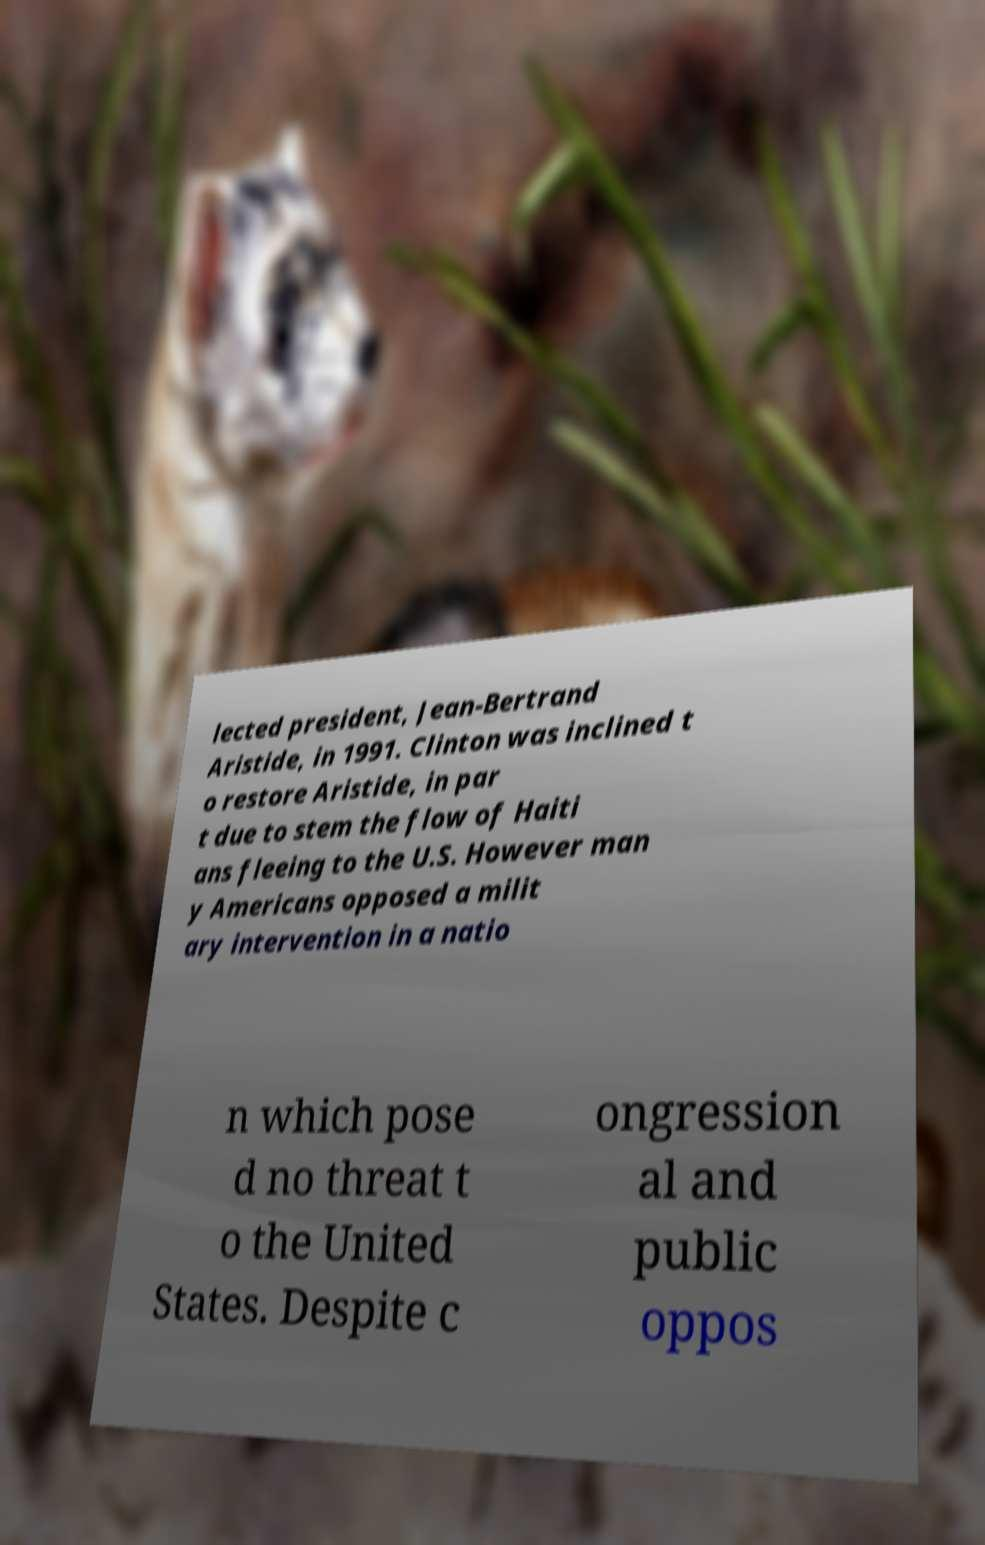There's text embedded in this image that I need extracted. Can you transcribe it verbatim? lected president, Jean-Bertrand Aristide, in 1991. Clinton was inclined t o restore Aristide, in par t due to stem the flow of Haiti ans fleeing to the U.S. However man y Americans opposed a milit ary intervention in a natio n which pose d no threat t o the United States. Despite c ongression al and public oppos 